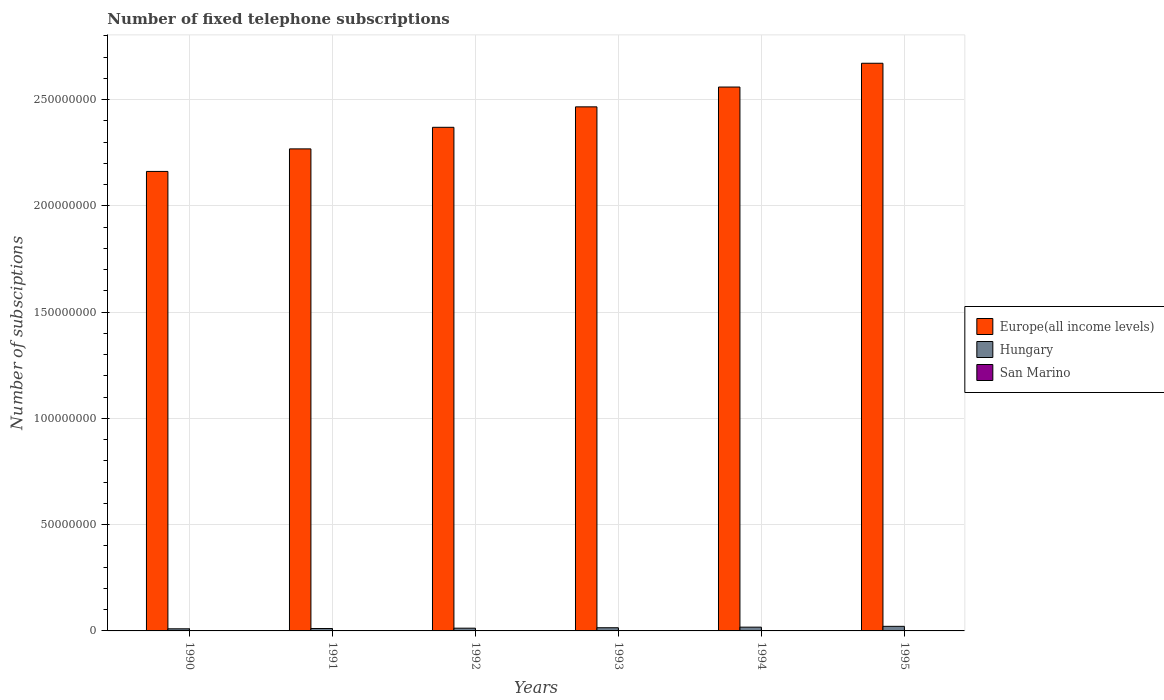How many different coloured bars are there?
Offer a very short reply. 3. Are the number of bars per tick equal to the number of legend labels?
Make the answer very short. Yes. Are the number of bars on each tick of the X-axis equal?
Your answer should be very brief. Yes. In how many cases, is the number of bars for a given year not equal to the number of legend labels?
Make the answer very short. 0. What is the number of fixed telephone subscriptions in San Marino in 1995?
Your response must be concise. 1.61e+04. Across all years, what is the maximum number of fixed telephone subscriptions in Hungary?
Offer a terse response. 2.16e+06. Across all years, what is the minimum number of fixed telephone subscriptions in Europe(all income levels)?
Offer a very short reply. 2.16e+08. In which year was the number of fixed telephone subscriptions in San Marino maximum?
Your answer should be compact. 1995. What is the total number of fixed telephone subscriptions in Europe(all income levels) in the graph?
Your answer should be very brief. 1.45e+09. What is the difference between the number of fixed telephone subscriptions in Hungary in 1990 and that in 1993?
Give a very brief answer. -5.02e+05. What is the difference between the number of fixed telephone subscriptions in Europe(all income levels) in 1991 and the number of fixed telephone subscriptions in San Marino in 1994?
Provide a succinct answer. 2.27e+08. What is the average number of fixed telephone subscriptions in Europe(all income levels) per year?
Provide a succinct answer. 2.42e+08. In the year 1995, what is the difference between the number of fixed telephone subscriptions in San Marino and number of fixed telephone subscriptions in Europe(all income levels)?
Make the answer very short. -2.67e+08. What is the ratio of the number of fixed telephone subscriptions in San Marino in 1991 to that in 1994?
Offer a terse response. 0.75. Is the number of fixed telephone subscriptions in Europe(all income levels) in 1990 less than that in 1992?
Make the answer very short. Yes. Is the difference between the number of fixed telephone subscriptions in San Marino in 1993 and 1995 greater than the difference between the number of fixed telephone subscriptions in Europe(all income levels) in 1993 and 1995?
Your response must be concise. Yes. What is the difference between the highest and the second highest number of fixed telephone subscriptions in Hungary?
Keep it short and to the point. 3.83e+05. What is the difference between the highest and the lowest number of fixed telephone subscriptions in Europe(all income levels)?
Ensure brevity in your answer.  5.09e+07. In how many years, is the number of fixed telephone subscriptions in San Marino greater than the average number of fixed telephone subscriptions in San Marino taken over all years?
Your answer should be very brief. 4. What does the 1st bar from the left in 1993 represents?
Your answer should be compact. Europe(all income levels). What does the 3rd bar from the right in 1994 represents?
Make the answer very short. Europe(all income levels). Is it the case that in every year, the sum of the number of fixed telephone subscriptions in Europe(all income levels) and number of fixed telephone subscriptions in Hungary is greater than the number of fixed telephone subscriptions in San Marino?
Ensure brevity in your answer.  Yes. How many bars are there?
Your answer should be compact. 18. Are all the bars in the graph horizontal?
Provide a short and direct response. No. How many years are there in the graph?
Ensure brevity in your answer.  6. Are the values on the major ticks of Y-axis written in scientific E-notation?
Provide a succinct answer. No. How many legend labels are there?
Provide a short and direct response. 3. What is the title of the graph?
Provide a short and direct response. Number of fixed telephone subscriptions. What is the label or title of the X-axis?
Your response must be concise. Years. What is the label or title of the Y-axis?
Provide a short and direct response. Number of subsciptions. What is the Number of subsciptions of Europe(all income levels) in 1990?
Offer a terse response. 2.16e+08. What is the Number of subsciptions in Hungary in 1990?
Your response must be concise. 9.96e+05. What is the Number of subsciptions of San Marino in 1990?
Your answer should be very brief. 1.02e+04. What is the Number of subsciptions in Europe(all income levels) in 1991?
Give a very brief answer. 2.27e+08. What is the Number of subsciptions of Hungary in 1991?
Make the answer very short. 1.13e+06. What is the Number of subsciptions of San Marino in 1991?
Keep it short and to the point. 1.08e+04. What is the Number of subsciptions of Europe(all income levels) in 1992?
Your response must be concise. 2.37e+08. What is the Number of subsciptions of Hungary in 1992?
Ensure brevity in your answer.  1.29e+06. What is the Number of subsciptions in San Marino in 1992?
Provide a succinct answer. 1.35e+04. What is the Number of subsciptions in Europe(all income levels) in 1993?
Give a very brief answer. 2.47e+08. What is the Number of subsciptions of Hungary in 1993?
Keep it short and to the point. 1.50e+06. What is the Number of subsciptions of San Marino in 1993?
Your answer should be very brief. 1.41e+04. What is the Number of subsciptions in Europe(all income levels) in 1994?
Your response must be concise. 2.56e+08. What is the Number of subsciptions of Hungary in 1994?
Your answer should be compact. 1.77e+06. What is the Number of subsciptions of San Marino in 1994?
Keep it short and to the point. 1.44e+04. What is the Number of subsciptions in Europe(all income levels) in 1995?
Your response must be concise. 2.67e+08. What is the Number of subsciptions of Hungary in 1995?
Your answer should be very brief. 2.16e+06. What is the Number of subsciptions in San Marino in 1995?
Provide a short and direct response. 1.61e+04. Across all years, what is the maximum Number of subsciptions of Europe(all income levels)?
Provide a short and direct response. 2.67e+08. Across all years, what is the maximum Number of subsciptions in Hungary?
Provide a succinct answer. 2.16e+06. Across all years, what is the maximum Number of subsciptions in San Marino?
Keep it short and to the point. 1.61e+04. Across all years, what is the minimum Number of subsciptions in Europe(all income levels)?
Keep it short and to the point. 2.16e+08. Across all years, what is the minimum Number of subsciptions of Hungary?
Give a very brief answer. 9.96e+05. Across all years, what is the minimum Number of subsciptions of San Marino?
Provide a succinct answer. 1.02e+04. What is the total Number of subsciptions in Europe(all income levels) in the graph?
Ensure brevity in your answer.  1.45e+09. What is the total Number of subsciptions of Hungary in the graph?
Offer a terse response. 8.84e+06. What is the total Number of subsciptions in San Marino in the graph?
Provide a succinct answer. 7.92e+04. What is the difference between the Number of subsciptions of Europe(all income levels) in 1990 and that in 1991?
Your response must be concise. -1.06e+07. What is the difference between the Number of subsciptions of Hungary in 1990 and that in 1991?
Make the answer very short. -1.32e+05. What is the difference between the Number of subsciptions in San Marino in 1990 and that in 1991?
Offer a terse response. -554. What is the difference between the Number of subsciptions in Europe(all income levels) in 1990 and that in 1992?
Offer a terse response. -2.08e+07. What is the difference between the Number of subsciptions of Hungary in 1990 and that in 1992?
Your answer should be compact. -2.95e+05. What is the difference between the Number of subsciptions of San Marino in 1990 and that in 1992?
Give a very brief answer. -3258. What is the difference between the Number of subsciptions of Europe(all income levels) in 1990 and that in 1993?
Your answer should be very brief. -3.04e+07. What is the difference between the Number of subsciptions in Hungary in 1990 and that in 1993?
Provide a succinct answer. -5.02e+05. What is the difference between the Number of subsciptions of San Marino in 1990 and that in 1993?
Provide a short and direct response. -3854. What is the difference between the Number of subsciptions in Europe(all income levels) in 1990 and that in 1994?
Keep it short and to the point. -3.97e+07. What is the difference between the Number of subsciptions in Hungary in 1990 and that in 1994?
Offer a terse response. -7.78e+05. What is the difference between the Number of subsciptions of San Marino in 1990 and that in 1994?
Offer a very short reply. -4186. What is the difference between the Number of subsciptions of Europe(all income levels) in 1990 and that in 1995?
Your answer should be very brief. -5.09e+07. What is the difference between the Number of subsciptions in Hungary in 1990 and that in 1995?
Provide a succinct answer. -1.16e+06. What is the difference between the Number of subsciptions of San Marino in 1990 and that in 1995?
Keep it short and to the point. -5842. What is the difference between the Number of subsciptions in Europe(all income levels) in 1991 and that in 1992?
Give a very brief answer. -1.02e+07. What is the difference between the Number of subsciptions of Hungary in 1991 and that in 1992?
Offer a very short reply. -1.63e+05. What is the difference between the Number of subsciptions in San Marino in 1991 and that in 1992?
Your answer should be very brief. -2704. What is the difference between the Number of subsciptions in Europe(all income levels) in 1991 and that in 1993?
Make the answer very short. -1.98e+07. What is the difference between the Number of subsciptions in Hungary in 1991 and that in 1993?
Give a very brief answer. -3.69e+05. What is the difference between the Number of subsciptions of San Marino in 1991 and that in 1993?
Give a very brief answer. -3300. What is the difference between the Number of subsciptions in Europe(all income levels) in 1991 and that in 1994?
Your answer should be very brief. -2.91e+07. What is the difference between the Number of subsciptions of Hungary in 1991 and that in 1994?
Your answer should be compact. -6.46e+05. What is the difference between the Number of subsciptions of San Marino in 1991 and that in 1994?
Your answer should be very brief. -3632. What is the difference between the Number of subsciptions in Europe(all income levels) in 1991 and that in 1995?
Provide a short and direct response. -4.03e+07. What is the difference between the Number of subsciptions of Hungary in 1991 and that in 1995?
Offer a very short reply. -1.03e+06. What is the difference between the Number of subsciptions in San Marino in 1991 and that in 1995?
Your answer should be compact. -5288. What is the difference between the Number of subsciptions in Europe(all income levels) in 1992 and that in 1993?
Your answer should be very brief. -9.62e+06. What is the difference between the Number of subsciptions of Hungary in 1992 and that in 1993?
Your answer should be compact. -2.06e+05. What is the difference between the Number of subsciptions of San Marino in 1992 and that in 1993?
Provide a short and direct response. -596. What is the difference between the Number of subsciptions of Europe(all income levels) in 1992 and that in 1994?
Your answer should be compact. -1.89e+07. What is the difference between the Number of subsciptions of Hungary in 1992 and that in 1994?
Your answer should be compact. -4.83e+05. What is the difference between the Number of subsciptions of San Marino in 1992 and that in 1994?
Offer a very short reply. -928. What is the difference between the Number of subsciptions of Europe(all income levels) in 1992 and that in 1995?
Provide a short and direct response. -3.01e+07. What is the difference between the Number of subsciptions in Hungary in 1992 and that in 1995?
Ensure brevity in your answer.  -8.66e+05. What is the difference between the Number of subsciptions in San Marino in 1992 and that in 1995?
Keep it short and to the point. -2584. What is the difference between the Number of subsciptions in Europe(all income levels) in 1993 and that in 1994?
Your answer should be compact. -9.32e+06. What is the difference between the Number of subsciptions of Hungary in 1993 and that in 1994?
Your answer should be compact. -2.77e+05. What is the difference between the Number of subsciptions in San Marino in 1993 and that in 1994?
Offer a terse response. -332. What is the difference between the Number of subsciptions of Europe(all income levels) in 1993 and that in 1995?
Give a very brief answer. -2.05e+07. What is the difference between the Number of subsciptions in Hungary in 1993 and that in 1995?
Offer a very short reply. -6.60e+05. What is the difference between the Number of subsciptions of San Marino in 1993 and that in 1995?
Ensure brevity in your answer.  -1988. What is the difference between the Number of subsciptions in Europe(all income levels) in 1994 and that in 1995?
Your answer should be very brief. -1.12e+07. What is the difference between the Number of subsciptions in Hungary in 1994 and that in 1995?
Offer a terse response. -3.83e+05. What is the difference between the Number of subsciptions of San Marino in 1994 and that in 1995?
Ensure brevity in your answer.  -1656. What is the difference between the Number of subsciptions in Europe(all income levels) in 1990 and the Number of subsciptions in Hungary in 1991?
Provide a succinct answer. 2.15e+08. What is the difference between the Number of subsciptions of Europe(all income levels) in 1990 and the Number of subsciptions of San Marino in 1991?
Offer a very short reply. 2.16e+08. What is the difference between the Number of subsciptions of Hungary in 1990 and the Number of subsciptions of San Marino in 1991?
Your answer should be compact. 9.85e+05. What is the difference between the Number of subsciptions in Europe(all income levels) in 1990 and the Number of subsciptions in Hungary in 1992?
Offer a terse response. 2.15e+08. What is the difference between the Number of subsciptions in Europe(all income levels) in 1990 and the Number of subsciptions in San Marino in 1992?
Your response must be concise. 2.16e+08. What is the difference between the Number of subsciptions in Hungary in 1990 and the Number of subsciptions in San Marino in 1992?
Make the answer very short. 9.82e+05. What is the difference between the Number of subsciptions in Europe(all income levels) in 1990 and the Number of subsciptions in Hungary in 1993?
Make the answer very short. 2.15e+08. What is the difference between the Number of subsciptions in Europe(all income levels) in 1990 and the Number of subsciptions in San Marino in 1993?
Offer a terse response. 2.16e+08. What is the difference between the Number of subsciptions of Hungary in 1990 and the Number of subsciptions of San Marino in 1993?
Provide a short and direct response. 9.82e+05. What is the difference between the Number of subsciptions in Europe(all income levels) in 1990 and the Number of subsciptions in Hungary in 1994?
Make the answer very short. 2.14e+08. What is the difference between the Number of subsciptions of Europe(all income levels) in 1990 and the Number of subsciptions of San Marino in 1994?
Give a very brief answer. 2.16e+08. What is the difference between the Number of subsciptions in Hungary in 1990 and the Number of subsciptions in San Marino in 1994?
Provide a short and direct response. 9.81e+05. What is the difference between the Number of subsciptions of Europe(all income levels) in 1990 and the Number of subsciptions of Hungary in 1995?
Give a very brief answer. 2.14e+08. What is the difference between the Number of subsciptions of Europe(all income levels) in 1990 and the Number of subsciptions of San Marino in 1995?
Give a very brief answer. 2.16e+08. What is the difference between the Number of subsciptions in Hungary in 1990 and the Number of subsciptions in San Marino in 1995?
Your answer should be very brief. 9.80e+05. What is the difference between the Number of subsciptions in Europe(all income levels) in 1991 and the Number of subsciptions in Hungary in 1992?
Offer a very short reply. 2.25e+08. What is the difference between the Number of subsciptions in Europe(all income levels) in 1991 and the Number of subsciptions in San Marino in 1992?
Provide a short and direct response. 2.27e+08. What is the difference between the Number of subsciptions of Hungary in 1991 and the Number of subsciptions of San Marino in 1992?
Make the answer very short. 1.11e+06. What is the difference between the Number of subsciptions of Europe(all income levels) in 1991 and the Number of subsciptions of Hungary in 1993?
Offer a very short reply. 2.25e+08. What is the difference between the Number of subsciptions of Europe(all income levels) in 1991 and the Number of subsciptions of San Marino in 1993?
Provide a succinct answer. 2.27e+08. What is the difference between the Number of subsciptions in Hungary in 1991 and the Number of subsciptions in San Marino in 1993?
Your answer should be compact. 1.11e+06. What is the difference between the Number of subsciptions in Europe(all income levels) in 1991 and the Number of subsciptions in Hungary in 1994?
Make the answer very short. 2.25e+08. What is the difference between the Number of subsciptions of Europe(all income levels) in 1991 and the Number of subsciptions of San Marino in 1994?
Provide a short and direct response. 2.27e+08. What is the difference between the Number of subsciptions in Hungary in 1991 and the Number of subsciptions in San Marino in 1994?
Your response must be concise. 1.11e+06. What is the difference between the Number of subsciptions of Europe(all income levels) in 1991 and the Number of subsciptions of Hungary in 1995?
Your response must be concise. 2.25e+08. What is the difference between the Number of subsciptions in Europe(all income levels) in 1991 and the Number of subsciptions in San Marino in 1995?
Offer a very short reply. 2.27e+08. What is the difference between the Number of subsciptions in Hungary in 1991 and the Number of subsciptions in San Marino in 1995?
Give a very brief answer. 1.11e+06. What is the difference between the Number of subsciptions of Europe(all income levels) in 1992 and the Number of subsciptions of Hungary in 1993?
Make the answer very short. 2.35e+08. What is the difference between the Number of subsciptions of Europe(all income levels) in 1992 and the Number of subsciptions of San Marino in 1993?
Offer a terse response. 2.37e+08. What is the difference between the Number of subsciptions in Hungary in 1992 and the Number of subsciptions in San Marino in 1993?
Your answer should be compact. 1.28e+06. What is the difference between the Number of subsciptions in Europe(all income levels) in 1992 and the Number of subsciptions in Hungary in 1994?
Offer a terse response. 2.35e+08. What is the difference between the Number of subsciptions in Europe(all income levels) in 1992 and the Number of subsciptions in San Marino in 1994?
Provide a succinct answer. 2.37e+08. What is the difference between the Number of subsciptions in Hungary in 1992 and the Number of subsciptions in San Marino in 1994?
Provide a short and direct response. 1.28e+06. What is the difference between the Number of subsciptions of Europe(all income levels) in 1992 and the Number of subsciptions of Hungary in 1995?
Provide a short and direct response. 2.35e+08. What is the difference between the Number of subsciptions of Europe(all income levels) in 1992 and the Number of subsciptions of San Marino in 1995?
Your answer should be compact. 2.37e+08. What is the difference between the Number of subsciptions of Hungary in 1992 and the Number of subsciptions of San Marino in 1995?
Offer a terse response. 1.28e+06. What is the difference between the Number of subsciptions of Europe(all income levels) in 1993 and the Number of subsciptions of Hungary in 1994?
Provide a succinct answer. 2.45e+08. What is the difference between the Number of subsciptions in Europe(all income levels) in 1993 and the Number of subsciptions in San Marino in 1994?
Keep it short and to the point. 2.47e+08. What is the difference between the Number of subsciptions of Hungary in 1993 and the Number of subsciptions of San Marino in 1994?
Keep it short and to the point. 1.48e+06. What is the difference between the Number of subsciptions in Europe(all income levels) in 1993 and the Number of subsciptions in Hungary in 1995?
Provide a short and direct response. 2.44e+08. What is the difference between the Number of subsciptions of Europe(all income levels) in 1993 and the Number of subsciptions of San Marino in 1995?
Provide a short and direct response. 2.47e+08. What is the difference between the Number of subsciptions in Hungary in 1993 and the Number of subsciptions in San Marino in 1995?
Make the answer very short. 1.48e+06. What is the difference between the Number of subsciptions in Europe(all income levels) in 1994 and the Number of subsciptions in Hungary in 1995?
Make the answer very short. 2.54e+08. What is the difference between the Number of subsciptions of Europe(all income levels) in 1994 and the Number of subsciptions of San Marino in 1995?
Your response must be concise. 2.56e+08. What is the difference between the Number of subsciptions in Hungary in 1994 and the Number of subsciptions in San Marino in 1995?
Offer a very short reply. 1.76e+06. What is the average Number of subsciptions in Europe(all income levels) per year?
Give a very brief answer. 2.42e+08. What is the average Number of subsciptions of Hungary per year?
Make the answer very short. 1.47e+06. What is the average Number of subsciptions of San Marino per year?
Give a very brief answer. 1.32e+04. In the year 1990, what is the difference between the Number of subsciptions of Europe(all income levels) and Number of subsciptions of Hungary?
Offer a terse response. 2.15e+08. In the year 1990, what is the difference between the Number of subsciptions in Europe(all income levels) and Number of subsciptions in San Marino?
Provide a succinct answer. 2.16e+08. In the year 1990, what is the difference between the Number of subsciptions of Hungary and Number of subsciptions of San Marino?
Offer a terse response. 9.86e+05. In the year 1991, what is the difference between the Number of subsciptions in Europe(all income levels) and Number of subsciptions in Hungary?
Make the answer very short. 2.26e+08. In the year 1991, what is the difference between the Number of subsciptions in Europe(all income levels) and Number of subsciptions in San Marino?
Provide a succinct answer. 2.27e+08. In the year 1991, what is the difference between the Number of subsciptions in Hungary and Number of subsciptions in San Marino?
Offer a very short reply. 1.12e+06. In the year 1992, what is the difference between the Number of subsciptions in Europe(all income levels) and Number of subsciptions in Hungary?
Your response must be concise. 2.36e+08. In the year 1992, what is the difference between the Number of subsciptions of Europe(all income levels) and Number of subsciptions of San Marino?
Keep it short and to the point. 2.37e+08. In the year 1992, what is the difference between the Number of subsciptions in Hungary and Number of subsciptions in San Marino?
Offer a very short reply. 1.28e+06. In the year 1993, what is the difference between the Number of subsciptions in Europe(all income levels) and Number of subsciptions in Hungary?
Keep it short and to the point. 2.45e+08. In the year 1993, what is the difference between the Number of subsciptions in Europe(all income levels) and Number of subsciptions in San Marino?
Offer a terse response. 2.47e+08. In the year 1993, what is the difference between the Number of subsciptions in Hungary and Number of subsciptions in San Marino?
Offer a very short reply. 1.48e+06. In the year 1994, what is the difference between the Number of subsciptions of Europe(all income levels) and Number of subsciptions of Hungary?
Provide a succinct answer. 2.54e+08. In the year 1994, what is the difference between the Number of subsciptions in Europe(all income levels) and Number of subsciptions in San Marino?
Make the answer very short. 2.56e+08. In the year 1994, what is the difference between the Number of subsciptions of Hungary and Number of subsciptions of San Marino?
Keep it short and to the point. 1.76e+06. In the year 1995, what is the difference between the Number of subsciptions in Europe(all income levels) and Number of subsciptions in Hungary?
Ensure brevity in your answer.  2.65e+08. In the year 1995, what is the difference between the Number of subsciptions of Europe(all income levels) and Number of subsciptions of San Marino?
Your answer should be compact. 2.67e+08. In the year 1995, what is the difference between the Number of subsciptions in Hungary and Number of subsciptions in San Marino?
Your response must be concise. 2.14e+06. What is the ratio of the Number of subsciptions in Europe(all income levels) in 1990 to that in 1991?
Your answer should be very brief. 0.95. What is the ratio of the Number of subsciptions in Hungary in 1990 to that in 1991?
Provide a short and direct response. 0.88. What is the ratio of the Number of subsciptions in San Marino in 1990 to that in 1991?
Your response must be concise. 0.95. What is the ratio of the Number of subsciptions in Europe(all income levels) in 1990 to that in 1992?
Your answer should be very brief. 0.91. What is the ratio of the Number of subsciptions of Hungary in 1990 to that in 1992?
Your answer should be very brief. 0.77. What is the ratio of the Number of subsciptions of San Marino in 1990 to that in 1992?
Ensure brevity in your answer.  0.76. What is the ratio of the Number of subsciptions of Europe(all income levels) in 1990 to that in 1993?
Your answer should be very brief. 0.88. What is the ratio of the Number of subsciptions in Hungary in 1990 to that in 1993?
Offer a very short reply. 0.67. What is the ratio of the Number of subsciptions of San Marino in 1990 to that in 1993?
Keep it short and to the point. 0.73. What is the ratio of the Number of subsciptions in Europe(all income levels) in 1990 to that in 1994?
Your answer should be very brief. 0.84. What is the ratio of the Number of subsciptions of Hungary in 1990 to that in 1994?
Make the answer very short. 0.56. What is the ratio of the Number of subsciptions in San Marino in 1990 to that in 1994?
Keep it short and to the point. 0.71. What is the ratio of the Number of subsciptions in Europe(all income levels) in 1990 to that in 1995?
Provide a short and direct response. 0.81. What is the ratio of the Number of subsciptions of Hungary in 1990 to that in 1995?
Your answer should be compact. 0.46. What is the ratio of the Number of subsciptions in San Marino in 1990 to that in 1995?
Keep it short and to the point. 0.64. What is the ratio of the Number of subsciptions of Europe(all income levels) in 1991 to that in 1992?
Ensure brevity in your answer.  0.96. What is the ratio of the Number of subsciptions of Hungary in 1991 to that in 1992?
Keep it short and to the point. 0.87. What is the ratio of the Number of subsciptions of San Marino in 1991 to that in 1992?
Offer a terse response. 0.8. What is the ratio of the Number of subsciptions of Europe(all income levels) in 1991 to that in 1993?
Your response must be concise. 0.92. What is the ratio of the Number of subsciptions of Hungary in 1991 to that in 1993?
Give a very brief answer. 0.75. What is the ratio of the Number of subsciptions of San Marino in 1991 to that in 1993?
Your response must be concise. 0.77. What is the ratio of the Number of subsciptions of Europe(all income levels) in 1991 to that in 1994?
Ensure brevity in your answer.  0.89. What is the ratio of the Number of subsciptions in Hungary in 1991 to that in 1994?
Make the answer very short. 0.64. What is the ratio of the Number of subsciptions of San Marino in 1991 to that in 1994?
Offer a terse response. 0.75. What is the ratio of the Number of subsciptions of Europe(all income levels) in 1991 to that in 1995?
Offer a terse response. 0.85. What is the ratio of the Number of subsciptions of Hungary in 1991 to that in 1995?
Ensure brevity in your answer.  0.52. What is the ratio of the Number of subsciptions in San Marino in 1991 to that in 1995?
Ensure brevity in your answer.  0.67. What is the ratio of the Number of subsciptions in Hungary in 1992 to that in 1993?
Offer a very short reply. 0.86. What is the ratio of the Number of subsciptions of San Marino in 1992 to that in 1993?
Your response must be concise. 0.96. What is the ratio of the Number of subsciptions of Europe(all income levels) in 1992 to that in 1994?
Provide a short and direct response. 0.93. What is the ratio of the Number of subsciptions of Hungary in 1992 to that in 1994?
Provide a short and direct response. 0.73. What is the ratio of the Number of subsciptions in San Marino in 1992 to that in 1994?
Ensure brevity in your answer.  0.94. What is the ratio of the Number of subsciptions of Europe(all income levels) in 1992 to that in 1995?
Keep it short and to the point. 0.89. What is the ratio of the Number of subsciptions in Hungary in 1992 to that in 1995?
Keep it short and to the point. 0.6. What is the ratio of the Number of subsciptions of San Marino in 1992 to that in 1995?
Your answer should be compact. 0.84. What is the ratio of the Number of subsciptions of Europe(all income levels) in 1993 to that in 1994?
Offer a very short reply. 0.96. What is the ratio of the Number of subsciptions of Hungary in 1993 to that in 1994?
Your answer should be compact. 0.84. What is the ratio of the Number of subsciptions of San Marino in 1993 to that in 1994?
Give a very brief answer. 0.98. What is the ratio of the Number of subsciptions of Europe(all income levels) in 1993 to that in 1995?
Offer a terse response. 0.92. What is the ratio of the Number of subsciptions of Hungary in 1993 to that in 1995?
Ensure brevity in your answer.  0.69. What is the ratio of the Number of subsciptions of San Marino in 1993 to that in 1995?
Your response must be concise. 0.88. What is the ratio of the Number of subsciptions in Europe(all income levels) in 1994 to that in 1995?
Ensure brevity in your answer.  0.96. What is the ratio of the Number of subsciptions of Hungary in 1994 to that in 1995?
Ensure brevity in your answer.  0.82. What is the ratio of the Number of subsciptions of San Marino in 1994 to that in 1995?
Your answer should be compact. 0.9. What is the difference between the highest and the second highest Number of subsciptions of Europe(all income levels)?
Ensure brevity in your answer.  1.12e+07. What is the difference between the highest and the second highest Number of subsciptions in Hungary?
Your response must be concise. 3.83e+05. What is the difference between the highest and the second highest Number of subsciptions in San Marino?
Your answer should be very brief. 1656. What is the difference between the highest and the lowest Number of subsciptions in Europe(all income levels)?
Your answer should be very brief. 5.09e+07. What is the difference between the highest and the lowest Number of subsciptions in Hungary?
Offer a terse response. 1.16e+06. What is the difference between the highest and the lowest Number of subsciptions of San Marino?
Make the answer very short. 5842. 